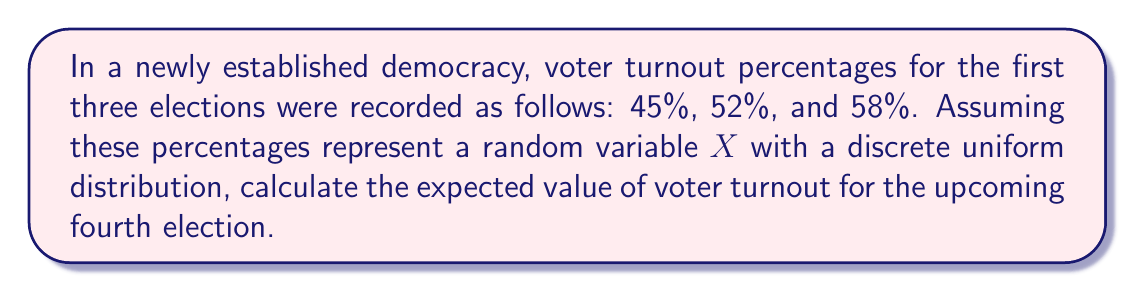Solve this math problem. To calculate the expected value of voter turnout, we'll follow these steps:

1) First, let's identify our random variable X:
   X = Voter turnout percentage

2) We have a discrete uniform distribution with three observed values:
   X = {45, 52, 58}

3) In a discrete uniform distribution, each outcome has an equal probability. With three outcomes, the probability of each is 1/3.

4) The formula for expected value is:
   $$E(X) = \sum_{i=1}^{n} x_i \cdot p(x_i)$$
   where $x_i$ are the possible values and $p(x_i)$ is the probability of each value.

5) Substituting our values:
   $$E(X) = 45 \cdot \frac{1}{3} + 52 \cdot \frac{1}{3} + 58 \cdot \frac{1}{3}$$

6) Simplifying:
   $$E(X) = \frac{45 + 52 + 58}{3} = \frac{155}{3} = 51.67$$

Therefore, based on the historical data and assuming a discrete uniform distribution, the expected value of voter turnout for the upcoming fourth election is 51.67%.
Answer: 51.67% 